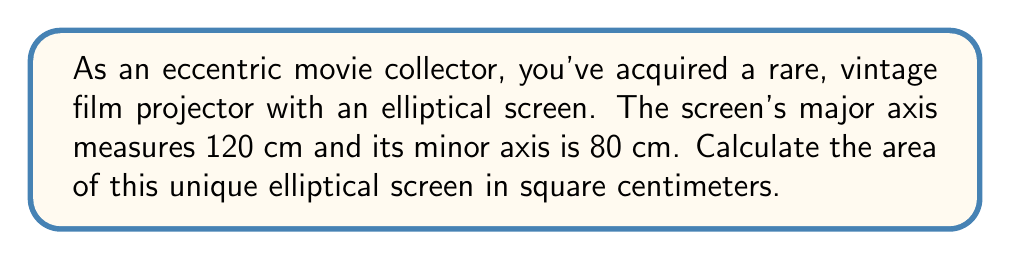Show me your answer to this math problem. To calculate the area of an elliptical screen, we use the formula:

$$A = \pi ab$$

Where:
$A$ = area of the ellipse
$a$ = length of the semi-major axis
$b$ = length of the semi-minor axis
$\pi$ ≈ 3.14159

Step 1: Determine the semi-major and semi-minor axes
Semi-major axis: $a = 120 \text{ cm} \div 2 = 60 \text{ cm}$
Semi-minor axis: $b = 80 \text{ cm} \div 2 = 40 \text{ cm}$

Step 2: Apply the formula
$$A = \pi ab$$
$$A = \pi (60 \text{ cm})(40 \text{ cm})$$
$$A = 2400\pi \text{ cm}^2$$

Step 3: Calculate the final result
$$A = 2400 \times 3.14159 \text{ cm}^2$$
$$A \approx 7539.82 \text{ cm}^2$$

Therefore, the area of the elliptical screen is approximately 7539.82 square centimeters.
Answer: $7539.82 \text{ cm}^2$ 